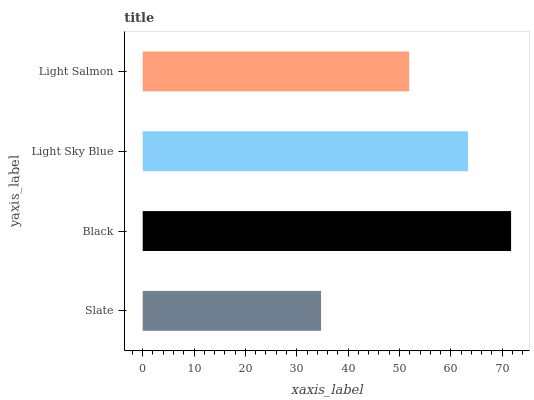Is Slate the minimum?
Answer yes or no. Yes. Is Black the maximum?
Answer yes or no. Yes. Is Light Sky Blue the minimum?
Answer yes or no. No. Is Light Sky Blue the maximum?
Answer yes or no. No. Is Black greater than Light Sky Blue?
Answer yes or no. Yes. Is Light Sky Blue less than Black?
Answer yes or no. Yes. Is Light Sky Blue greater than Black?
Answer yes or no. No. Is Black less than Light Sky Blue?
Answer yes or no. No. Is Light Sky Blue the high median?
Answer yes or no. Yes. Is Light Salmon the low median?
Answer yes or no. Yes. Is Slate the high median?
Answer yes or no. No. Is Light Sky Blue the low median?
Answer yes or no. No. 